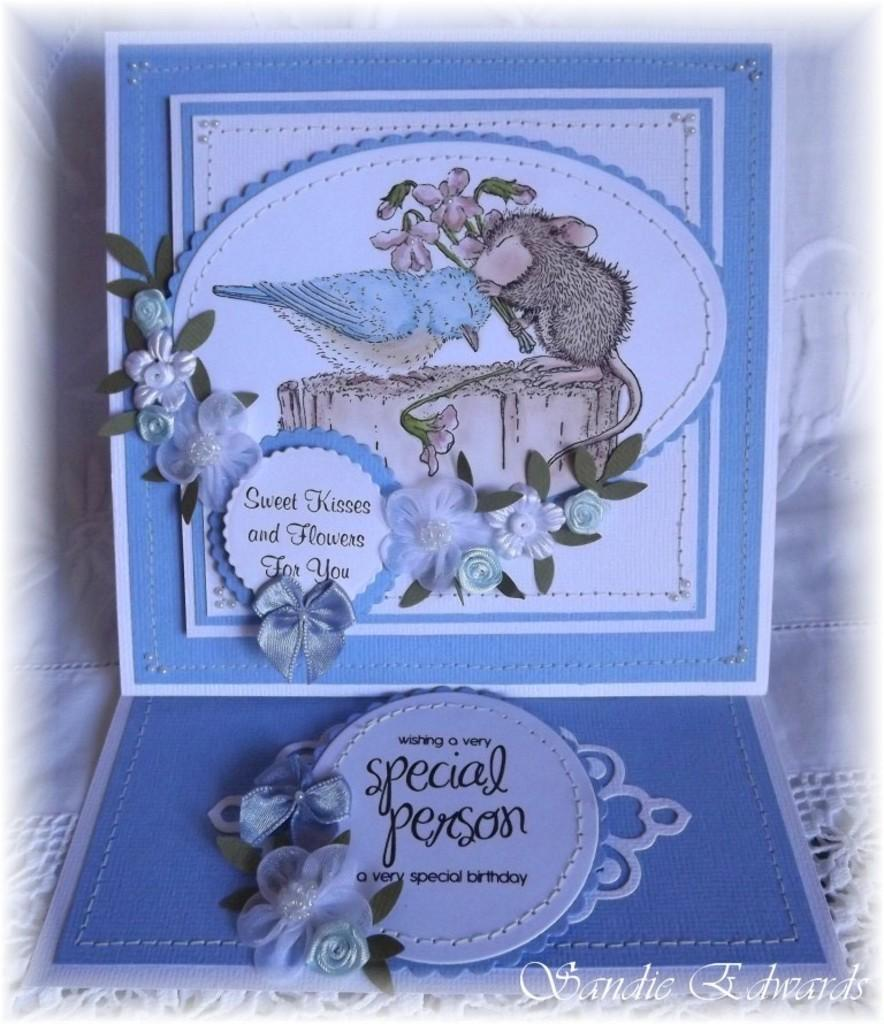What color is dominant in the image? The dominant color in the image is blue. What is written on the blue color things? Something is written on the blue color things in the image. What type of flora is depicted in the image? There is a depiction of flowers in the image. What type of fauna is depicted in the image? There is a depiction of a bird and a rat in the image. What is the daily income of the rat depicted in the image? There is no information about the rat's income in the image, as it is a depiction and not a real rat. How many times does the bird sneeze in the image? There is no indication of the bird sneezing in the image, as it is a depiction and not a real bird. 